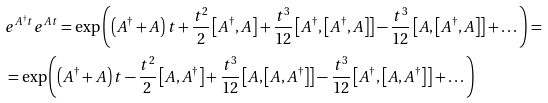<formula> <loc_0><loc_0><loc_500><loc_500>& e ^ { A ^ { \dag } t } e ^ { A t } = \exp \left ( \left ( A ^ { \dag } + A \right ) t + \frac { t ^ { 2 } } { 2 } \left [ A ^ { \dag } , A \right ] + \frac { t ^ { 3 } } { 1 2 } \left [ A ^ { \dag } , \left [ A ^ { \dag } , A \right ] \right ] - \frac { t ^ { 3 } } { 1 2 } \left [ A , \left [ A ^ { \dag } , A \right ] \right ] + \dots \right ) = \\ & = \exp \left ( \left ( A ^ { \dag } + A \right ) t - \frac { t ^ { 2 } } { 2 } \left [ A , A ^ { \dag } \right ] + \frac { t ^ { 3 } } { 1 2 } \left [ A , \left [ A , A ^ { \dag } \right ] \right ] - \frac { t ^ { 3 } } { 1 2 } \left [ A ^ { \dag } , \left [ A , A ^ { \dag } \right ] \right ] + \dots \right )</formula> 